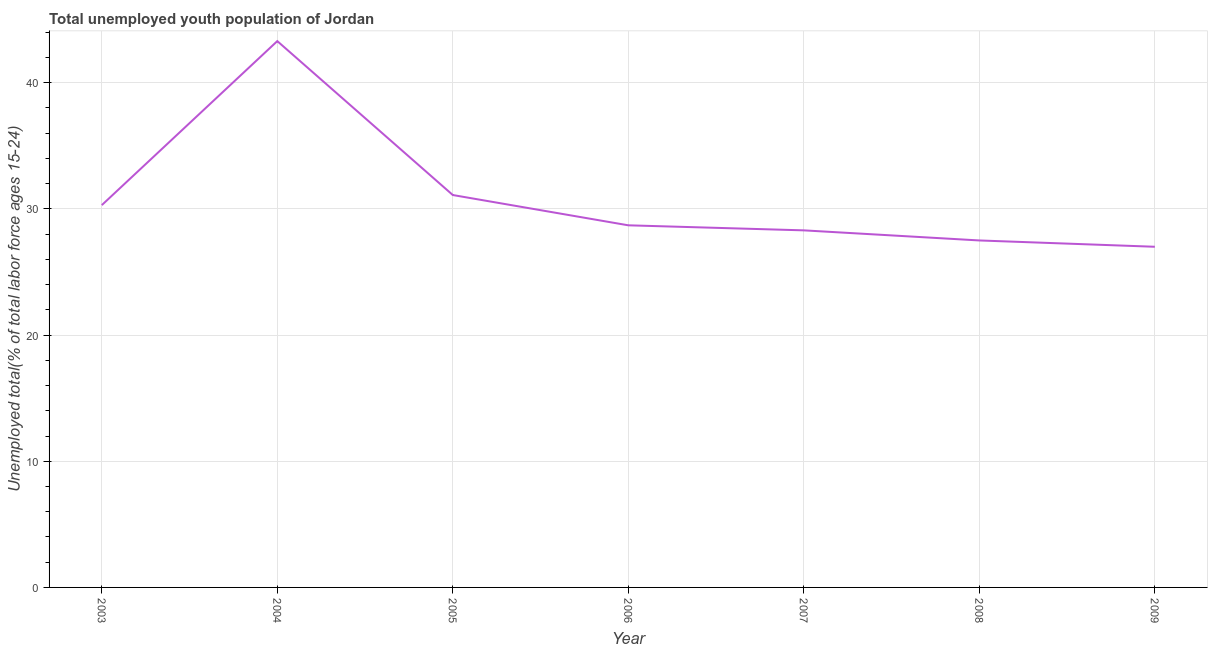Across all years, what is the maximum unemployed youth?
Offer a very short reply. 43.3. In which year was the unemployed youth minimum?
Make the answer very short. 2009. What is the sum of the unemployed youth?
Offer a very short reply. 216.2. What is the difference between the unemployed youth in 2003 and 2005?
Your response must be concise. -0.8. What is the average unemployed youth per year?
Ensure brevity in your answer.  30.89. What is the median unemployed youth?
Your answer should be very brief. 28.7. In how many years, is the unemployed youth greater than 40 %?
Make the answer very short. 1. Do a majority of the years between 2006 and 2008 (inclusive) have unemployed youth greater than 8 %?
Your answer should be very brief. Yes. What is the ratio of the unemployed youth in 2004 to that in 2007?
Your answer should be compact. 1.53. Is the unemployed youth in 2004 less than that in 2008?
Your answer should be compact. No. Is the difference between the unemployed youth in 2008 and 2009 greater than the difference between any two years?
Make the answer very short. No. What is the difference between the highest and the second highest unemployed youth?
Offer a very short reply. 12.2. What is the difference between the highest and the lowest unemployed youth?
Offer a very short reply. 16.3. Does the unemployed youth monotonically increase over the years?
Offer a terse response. No. How many lines are there?
Your response must be concise. 1. How many years are there in the graph?
Your answer should be compact. 7. What is the difference between two consecutive major ticks on the Y-axis?
Offer a very short reply. 10. Does the graph contain any zero values?
Ensure brevity in your answer.  No. What is the title of the graph?
Provide a short and direct response. Total unemployed youth population of Jordan. What is the label or title of the Y-axis?
Your answer should be compact. Unemployed total(% of total labor force ages 15-24). What is the Unemployed total(% of total labor force ages 15-24) in 2003?
Ensure brevity in your answer.  30.3. What is the Unemployed total(% of total labor force ages 15-24) in 2004?
Give a very brief answer. 43.3. What is the Unemployed total(% of total labor force ages 15-24) of 2005?
Provide a succinct answer. 31.1. What is the Unemployed total(% of total labor force ages 15-24) in 2006?
Provide a succinct answer. 28.7. What is the Unemployed total(% of total labor force ages 15-24) in 2007?
Your response must be concise. 28.3. What is the Unemployed total(% of total labor force ages 15-24) of 2008?
Your answer should be very brief. 27.5. What is the Unemployed total(% of total labor force ages 15-24) of 2009?
Your answer should be very brief. 27. What is the difference between the Unemployed total(% of total labor force ages 15-24) in 2003 and 2005?
Your answer should be very brief. -0.8. What is the difference between the Unemployed total(% of total labor force ages 15-24) in 2003 and 2009?
Give a very brief answer. 3.3. What is the difference between the Unemployed total(% of total labor force ages 15-24) in 2004 and 2008?
Give a very brief answer. 15.8. What is the difference between the Unemployed total(% of total labor force ages 15-24) in 2005 and 2007?
Give a very brief answer. 2.8. What is the difference between the Unemployed total(% of total labor force ages 15-24) in 2005 and 2008?
Offer a terse response. 3.6. What is the difference between the Unemployed total(% of total labor force ages 15-24) in 2006 and 2007?
Give a very brief answer. 0.4. What is the difference between the Unemployed total(% of total labor force ages 15-24) in 2006 and 2008?
Provide a succinct answer. 1.2. What is the difference between the Unemployed total(% of total labor force ages 15-24) in 2008 and 2009?
Your response must be concise. 0.5. What is the ratio of the Unemployed total(% of total labor force ages 15-24) in 2003 to that in 2004?
Give a very brief answer. 0.7. What is the ratio of the Unemployed total(% of total labor force ages 15-24) in 2003 to that in 2005?
Keep it short and to the point. 0.97. What is the ratio of the Unemployed total(% of total labor force ages 15-24) in 2003 to that in 2006?
Offer a very short reply. 1.06. What is the ratio of the Unemployed total(% of total labor force ages 15-24) in 2003 to that in 2007?
Your response must be concise. 1.07. What is the ratio of the Unemployed total(% of total labor force ages 15-24) in 2003 to that in 2008?
Ensure brevity in your answer.  1.1. What is the ratio of the Unemployed total(% of total labor force ages 15-24) in 2003 to that in 2009?
Provide a short and direct response. 1.12. What is the ratio of the Unemployed total(% of total labor force ages 15-24) in 2004 to that in 2005?
Your answer should be very brief. 1.39. What is the ratio of the Unemployed total(% of total labor force ages 15-24) in 2004 to that in 2006?
Your response must be concise. 1.51. What is the ratio of the Unemployed total(% of total labor force ages 15-24) in 2004 to that in 2007?
Offer a very short reply. 1.53. What is the ratio of the Unemployed total(% of total labor force ages 15-24) in 2004 to that in 2008?
Offer a very short reply. 1.57. What is the ratio of the Unemployed total(% of total labor force ages 15-24) in 2004 to that in 2009?
Ensure brevity in your answer.  1.6. What is the ratio of the Unemployed total(% of total labor force ages 15-24) in 2005 to that in 2006?
Provide a succinct answer. 1.08. What is the ratio of the Unemployed total(% of total labor force ages 15-24) in 2005 to that in 2007?
Provide a succinct answer. 1.1. What is the ratio of the Unemployed total(% of total labor force ages 15-24) in 2005 to that in 2008?
Offer a very short reply. 1.13. What is the ratio of the Unemployed total(% of total labor force ages 15-24) in 2005 to that in 2009?
Keep it short and to the point. 1.15. What is the ratio of the Unemployed total(% of total labor force ages 15-24) in 2006 to that in 2007?
Your answer should be very brief. 1.01. What is the ratio of the Unemployed total(% of total labor force ages 15-24) in 2006 to that in 2008?
Offer a very short reply. 1.04. What is the ratio of the Unemployed total(% of total labor force ages 15-24) in 2006 to that in 2009?
Your answer should be compact. 1.06. What is the ratio of the Unemployed total(% of total labor force ages 15-24) in 2007 to that in 2008?
Your answer should be very brief. 1.03. What is the ratio of the Unemployed total(% of total labor force ages 15-24) in 2007 to that in 2009?
Your answer should be compact. 1.05. 